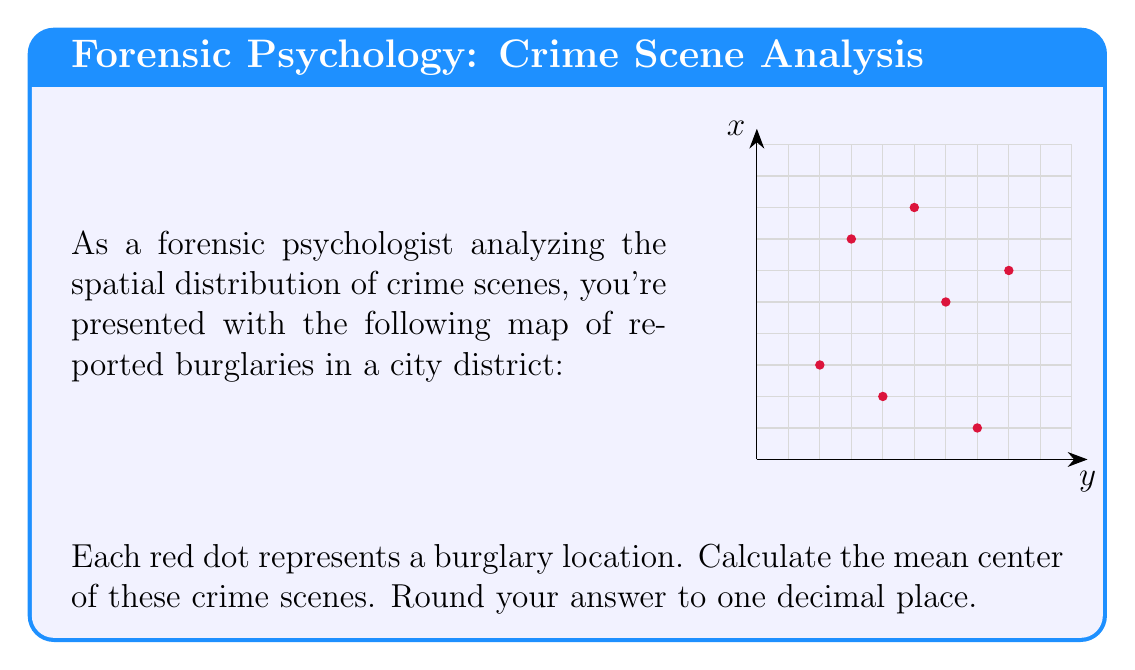Show me your answer to this math problem. To find the mean center of the crime scenes, we need to calculate the average x-coordinate and the average y-coordinate of all the points. This will give us the coordinates of the mean center.

Step 1: List all the coordinates (x, y) of the crime scenes:
(2, 3), (3, 7), (4, 2), (5, 8), (6, 5), (7, 1), (8, 6)

Step 2: Calculate the average x-coordinate:
$$\bar{x} = \frac{2 + 3 + 4 + 5 + 6 + 7 + 8}{7} = \frac{35}{7} = 5$$

Step 3: Calculate the average y-coordinate:
$$\bar{y} = \frac{3 + 7 + 2 + 8 + 5 + 1 + 6}{7} = \frac{32}{7} \approx 4.57$$

Step 4: Round both coordinates to one decimal place:
$\bar{x} = 5.0$
$\bar{y} = 4.6$

Therefore, the mean center of the crime scenes is at the point (5.0, 4.6).
Answer: (5.0, 4.6) 